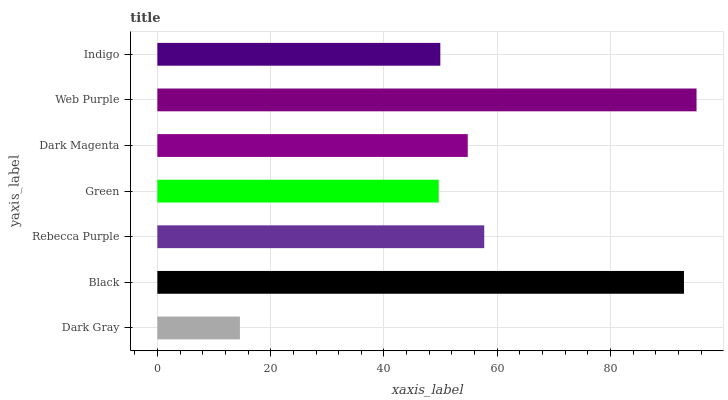Is Dark Gray the minimum?
Answer yes or no. Yes. Is Web Purple the maximum?
Answer yes or no. Yes. Is Black the minimum?
Answer yes or no. No. Is Black the maximum?
Answer yes or no. No. Is Black greater than Dark Gray?
Answer yes or no. Yes. Is Dark Gray less than Black?
Answer yes or no. Yes. Is Dark Gray greater than Black?
Answer yes or no. No. Is Black less than Dark Gray?
Answer yes or no. No. Is Dark Magenta the high median?
Answer yes or no. Yes. Is Dark Magenta the low median?
Answer yes or no. Yes. Is Web Purple the high median?
Answer yes or no. No. Is Indigo the low median?
Answer yes or no. No. 